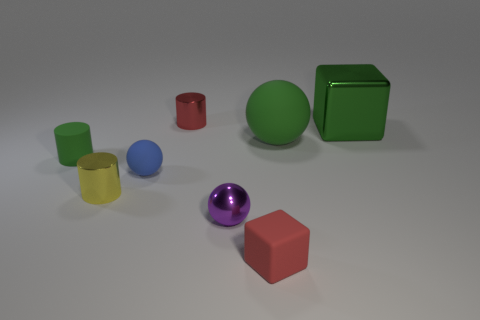The big metal thing that is the same color as the small rubber cylinder is what shape?
Your response must be concise. Cube. Are there fewer red cubes than purple matte things?
Provide a short and direct response. No. There is a green metallic object; is it the same shape as the red thing that is in front of the big green block?
Offer a very short reply. Yes. There is a metal thing that is in front of the yellow metallic cylinder; is its size the same as the tiny red shiny cylinder?
Keep it short and to the point. Yes. There is a red matte thing that is the same size as the yellow metallic cylinder; what shape is it?
Offer a very short reply. Cube. Does the purple metallic object have the same shape as the small blue object?
Your response must be concise. Yes. How many small shiny things have the same shape as the small blue rubber thing?
Your answer should be compact. 1. How many metal cylinders are in front of the big green ball?
Make the answer very short. 1. There is a block that is behind the tiny metal sphere; is it the same color as the small rubber cylinder?
Ensure brevity in your answer.  Yes. How many brown matte balls have the same size as the purple ball?
Your answer should be compact. 0. 